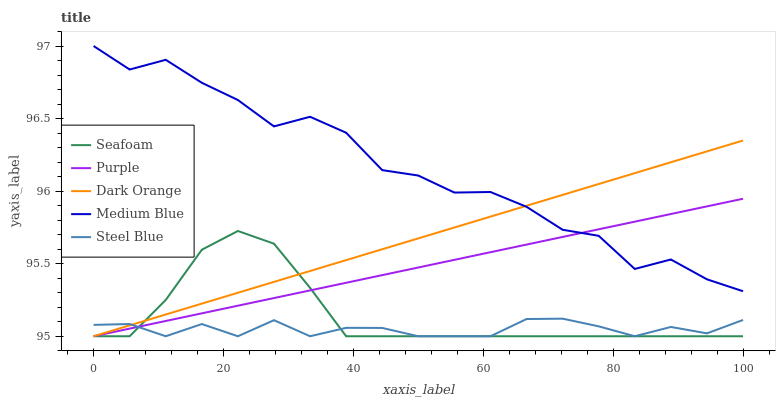Does Steel Blue have the minimum area under the curve?
Answer yes or no. Yes. Does Medium Blue have the maximum area under the curve?
Answer yes or no. Yes. Does Dark Orange have the minimum area under the curve?
Answer yes or no. No. Does Dark Orange have the maximum area under the curve?
Answer yes or no. No. Is Purple the smoothest?
Answer yes or no. Yes. Is Medium Blue the roughest?
Answer yes or no. Yes. Is Dark Orange the smoothest?
Answer yes or no. No. Is Dark Orange the roughest?
Answer yes or no. No. Does Purple have the lowest value?
Answer yes or no. Yes. Does Medium Blue have the lowest value?
Answer yes or no. No. Does Medium Blue have the highest value?
Answer yes or no. Yes. Does Dark Orange have the highest value?
Answer yes or no. No. Is Seafoam less than Medium Blue?
Answer yes or no. Yes. Is Medium Blue greater than Seafoam?
Answer yes or no. Yes. Does Steel Blue intersect Seafoam?
Answer yes or no. Yes. Is Steel Blue less than Seafoam?
Answer yes or no. No. Is Steel Blue greater than Seafoam?
Answer yes or no. No. Does Seafoam intersect Medium Blue?
Answer yes or no. No. 